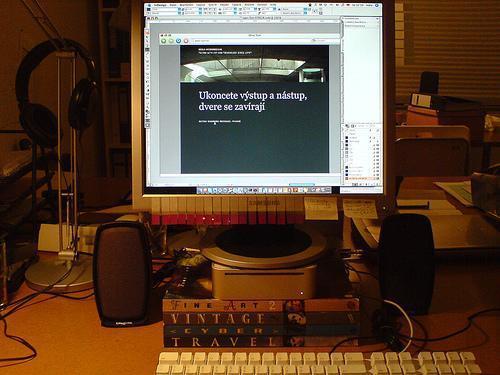How many speakers are there?
Give a very brief answer. 2. 